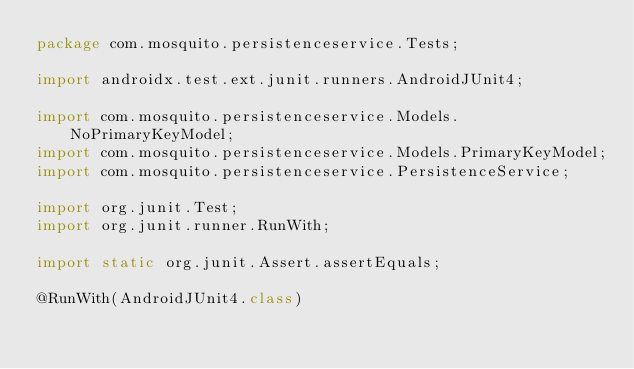<code> <loc_0><loc_0><loc_500><loc_500><_Java_>package com.mosquito.persistenceservice.Tests;

import androidx.test.ext.junit.runners.AndroidJUnit4;

import com.mosquito.persistenceservice.Models.NoPrimaryKeyModel;
import com.mosquito.persistenceservice.Models.PrimaryKeyModel;
import com.mosquito.persistenceservice.PersistenceService;

import org.junit.Test;
import org.junit.runner.RunWith;

import static org.junit.Assert.assertEquals;

@RunWith(AndroidJUnit4.class)</code> 